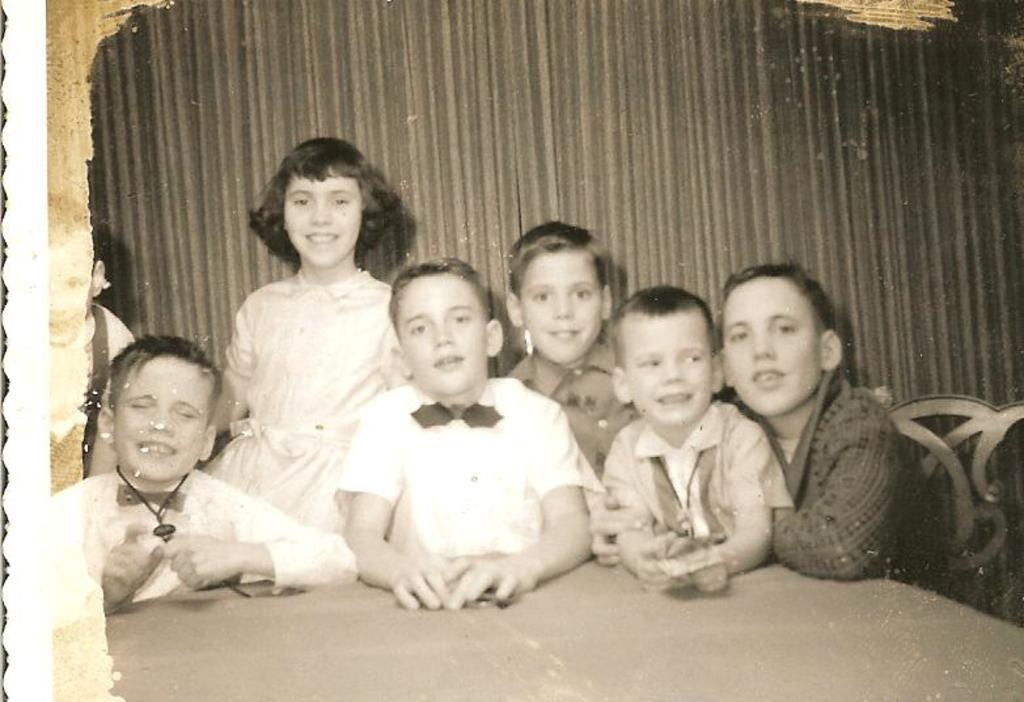What is the color scheme of the image? The image is black and white. What type of furniture can be seen in the image? There is a table and a chair in the image. What can be seen in the background of the image? There is a group of people in the background of the image. What type of window treatment is present in the image? There is a curtain in the image. What type of bone is visible on the table in the image? There is no bone present on the table in the image. What type of jam is being served to the group of people in the image? There is no jam present in the image; it is a black and white image with no visible food items. 